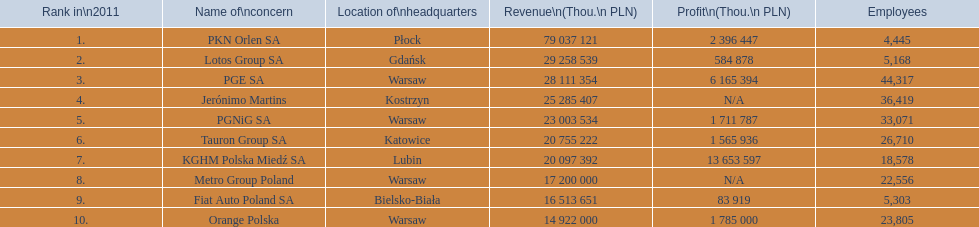What are all the concerns called? PKN Orlen SA, Lotos Group SA, PGE SA, Jerónimo Martins, PGNiG SA, Tauron Group SA, KGHM Polska Miedź SA, Metro Group Poland, Fiat Auto Poland SA, Orange Polska. What is the total number of employees at pgnig sa? 33,071. 